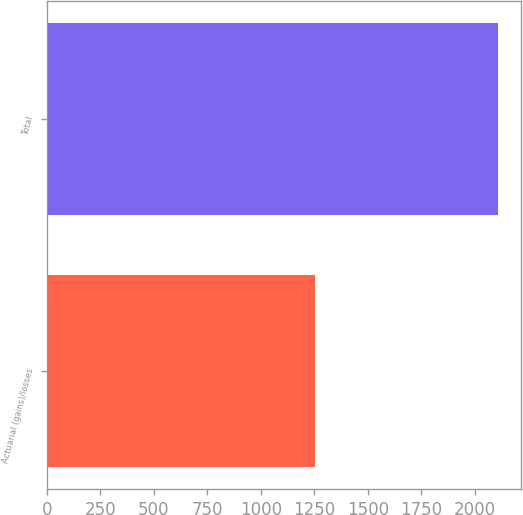<chart> <loc_0><loc_0><loc_500><loc_500><bar_chart><fcel>Actuarial (gains)/losses<fcel>Total<nl><fcel>1251<fcel>2110<nl></chart> 